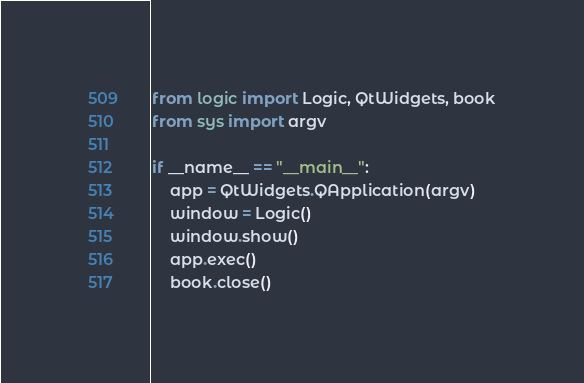Convert code to text. <code><loc_0><loc_0><loc_500><loc_500><_Python_>from logic import Logic, QtWidgets, book
from sys import argv

if __name__ == "__main__":
    app = QtWidgets.QApplication(argv)
    window = Logic()
    window.show()
    app.exec()
    book.close()
</code> 